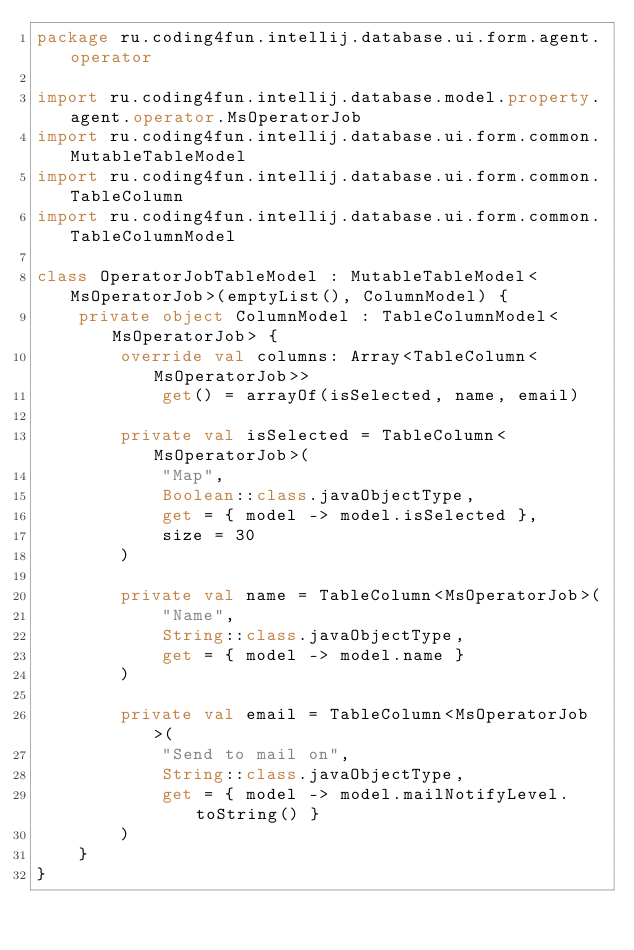Convert code to text. <code><loc_0><loc_0><loc_500><loc_500><_Kotlin_>package ru.coding4fun.intellij.database.ui.form.agent.operator

import ru.coding4fun.intellij.database.model.property.agent.operator.MsOperatorJob
import ru.coding4fun.intellij.database.ui.form.common.MutableTableModel
import ru.coding4fun.intellij.database.ui.form.common.TableColumn
import ru.coding4fun.intellij.database.ui.form.common.TableColumnModel

class OperatorJobTableModel : MutableTableModel<MsOperatorJob>(emptyList(), ColumnModel) {
	private object ColumnModel : TableColumnModel<MsOperatorJob> {
		override val columns: Array<TableColumn<MsOperatorJob>>
			get() = arrayOf(isSelected, name, email)

		private val isSelected = TableColumn<MsOperatorJob>(
			"Map",
			Boolean::class.javaObjectType,
			get = { model -> model.isSelected },
			size = 30
		)

		private val name = TableColumn<MsOperatorJob>(
			"Name",
			String::class.javaObjectType,
			get = { model -> model.name }
		)

		private val email = TableColumn<MsOperatorJob>(
			"Send to mail on",
			String::class.javaObjectType,
			get = { model -> model.mailNotifyLevel.toString() }
		)
	}
}</code> 